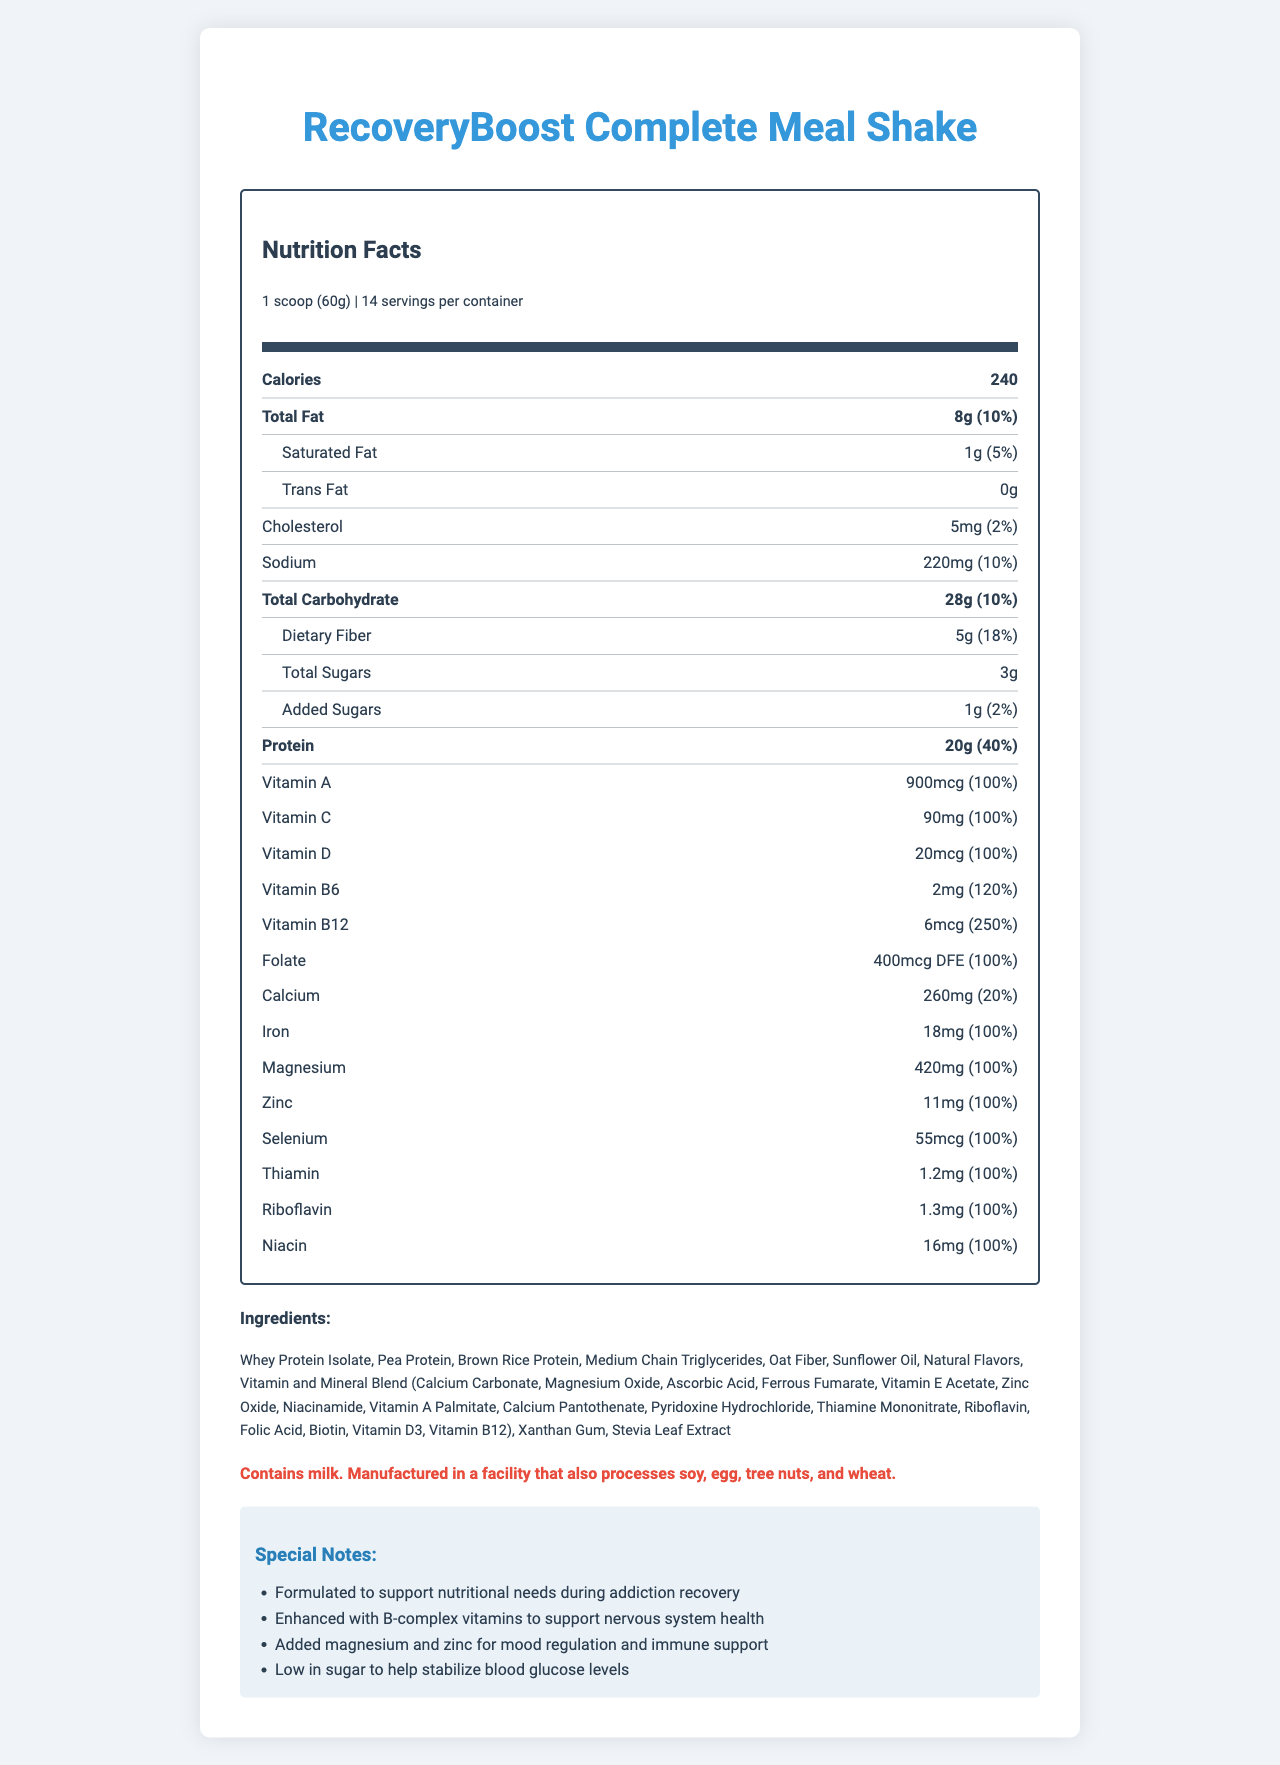What is the serving size for RecoveryBoost Complete Meal Shake? The document specifies that the serving size is "1 scoop (60g)".
Answer: 1 scoop (60g) How many servings are contained in one container of RecoveryBoost Complete Meal Shake? The document explicitly states that there are 14 servings per container.
Answer: 14 How much protein does one serving of RecoveryBoost Complete Meal Shake provide? The Nutrition Facts label indicates that each serving contains 20g of protein.
Answer: 20g What percentage of the Daily Value for Vitamin C is provided by one serving? The Nutrition Facts label shows that one serving contains 90mg of Vitamin C, which is 100% of the Daily Value.
Answer: 100% Which of the following vitamins has the highest Daily Value percentage in RecoveryBoost Complete Meal Shake?
A. Vitamin A
B. Vitamin D
C. Vitamin B12
D. Folate Vitamin B12 provides 250% of the Daily Value, which is the highest among the listed options.
Answer: C What is the amount of dietary fiber in one serving? The document indicates that there are 5g of dietary fiber per serving.
Answer: 5g What is the total amount of sugars, including added sugars, in one serving? The document shows that there are 3g of total sugars and 1g of added sugars, totaling 4g of sugar per serving.
Answer: 4g What is the special note mentioned about the B-complex vitamins? The special notes section lists that the product is enhanced with B-complex vitamins to support nervous system health.
Answer: Enhanced with B-complex vitamins to support nervous system health What is the main ingredient used in this meal shake? A. Soy Protein Isolate B. Whey Protein Isolate C. Coconut Oil D. Corn Syrup The first ingredient listed is Whey Protein Isolate.
Answer: B Does the product contain any trans fats? The Nutrition Facts label indicates that the product contains 0g of trans fats.
Answer: No What nutrients have a Daily Value percentage of exactly 100% per serving? The document lists these nutrients as having a Daily Value of 100% per serving.
Answer: Vitamin A, Vitamin C, Vitamin D, Folate, Iron, Magnesium, Zinc, Thiamin, Riboflavin, Niacin What is the allergen warning associated with RecoveryBoost Complete Meal Shake? The allergen warning is provided in the document explicitly.
Answer: Contains milk. Manufactured in a facility that also processes soy, egg, tree nuts, and wheat. How is RecoveryBoost Complete Meal Shake formulated to support recovering addicts? The special notes section provides detailed support mechanisms targeted for recovering addicts.
Answer: By supporting nutritional needs during addiction recovery, enhancing B-complex vitamins for nervous system health, adding magnesium and zinc for mood regulation and immune support, and being low in sugar. What is the document about? The document provides comprehensive nutritional information and highlights the specific benefits for individuals in addiction recovery.
Answer: The document is a detailed Nutrition Facts label for RecoveryBoost Complete Meal Shake, providing information on serving size, calories, macronutrient and micronutrient contents, ingredients, allergen warning, and special notes on how the product supports nutritional needs during addiction recovery. What is the manufacturer of the RecoveryBoost Complete Meal Shake? The document does not provide information about the manufacturer of RecoveryBoost Complete Meal Shake.
Answer: Not enough information 